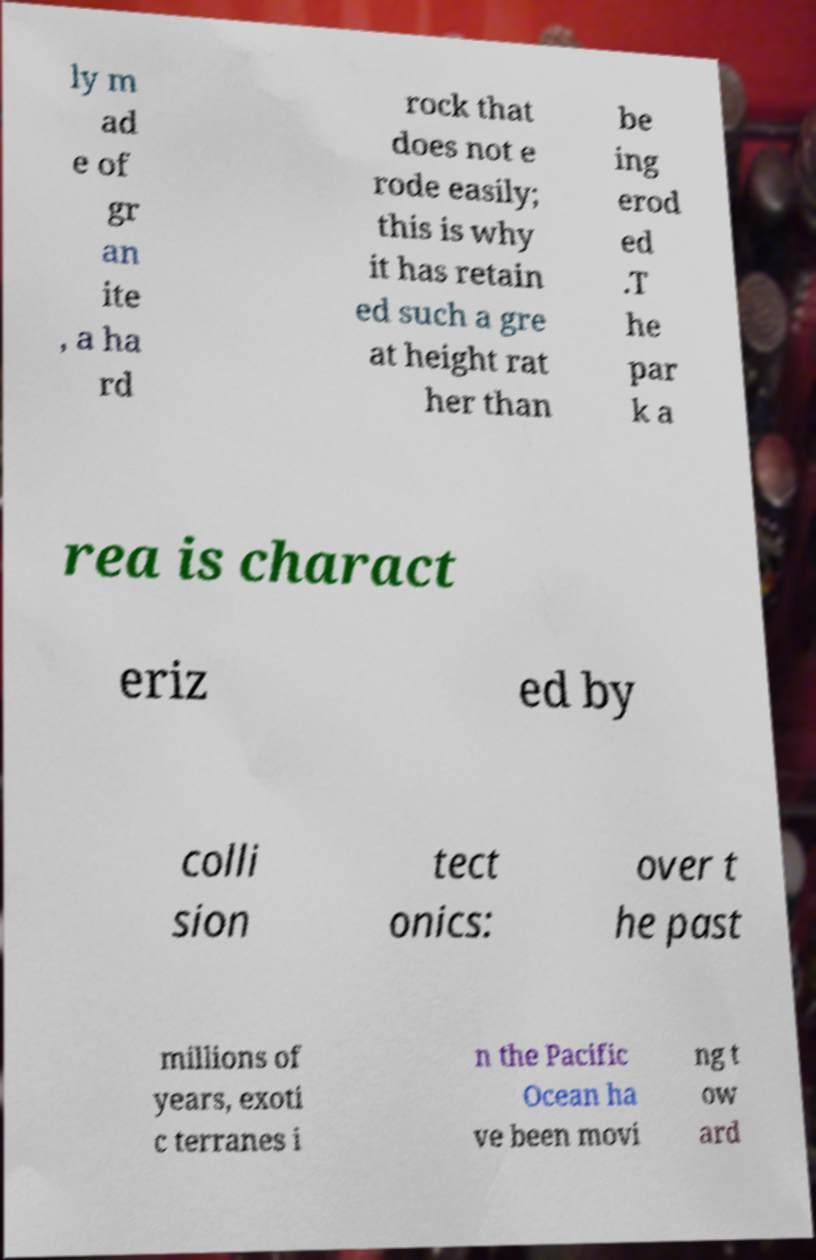There's text embedded in this image that I need extracted. Can you transcribe it verbatim? ly m ad e of gr an ite , a ha rd rock that does not e rode easily; this is why it has retain ed such a gre at height rat her than be ing erod ed .T he par k a rea is charact eriz ed by colli sion tect onics: over t he past millions of years, exoti c terranes i n the Pacific Ocean ha ve been movi ng t ow ard 